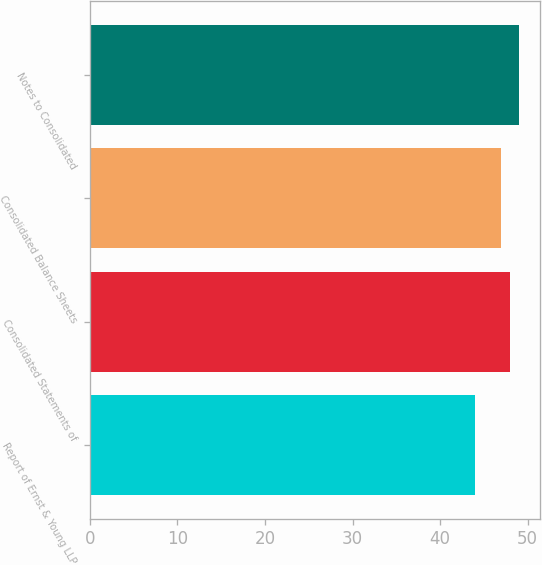<chart> <loc_0><loc_0><loc_500><loc_500><bar_chart><fcel>Report of Ernst & Young LLP<fcel>Consolidated Statements of<fcel>Consolidated Balance Sheets<fcel>Notes to Consolidated<nl><fcel>44<fcel>48<fcel>47<fcel>49<nl></chart> 